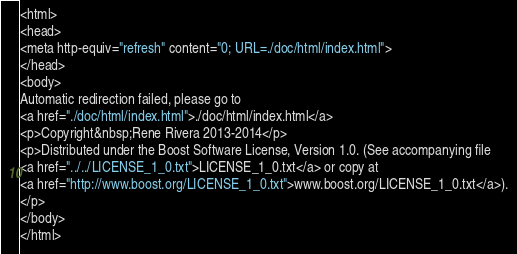<code> <loc_0><loc_0><loc_500><loc_500><_HTML_><html>
<head>
<meta http-equiv="refresh" content="0; URL=./doc/html/index.html">
</head>
<body>
Automatic redirection failed, please go to
<a href="./doc/html/index.html">./doc/html/index.html</a>
<p>Copyright&nbsp;Rene Rivera 2013-2014</p>
<p>Distributed under the Boost Software License, Version 1.0. (See accompanying file
<a href="../../LICENSE_1_0.txt">LICENSE_1_0.txt</a> or copy at
<a href="http://www.boost.org/LICENSE_1_0.txt">www.boost.org/LICENSE_1_0.txt</a>).
</p>
</body>
</html>
</code> 